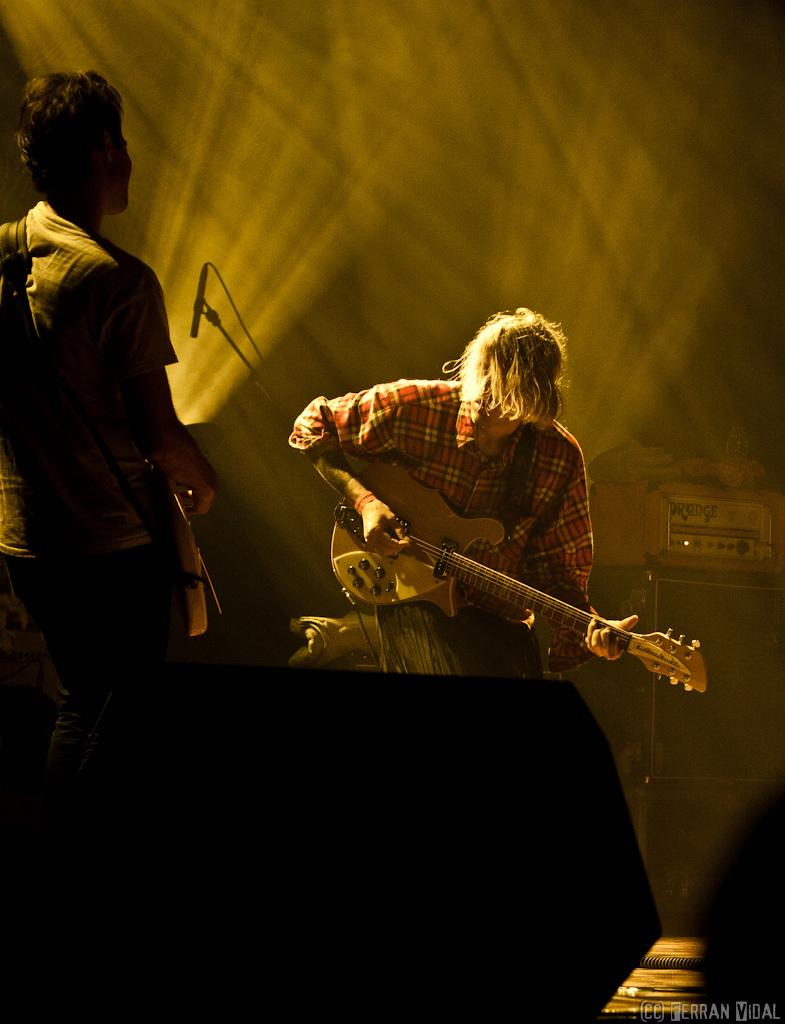How many people are in the image? There are two persons in the image. What are the two persons doing? The two persons are playing guitar. What is the position of the two persons in the image? The two persons are standing. What object is present in the image that might amplify sound? There is a speaker in the image. What is attached to the speaker in the image? There is a device on the speaker. What type of mint can be seen growing near the gate in the image? There is no mint or gate present in the image; it features two persons playing guitar and a speaker with a device on it. 